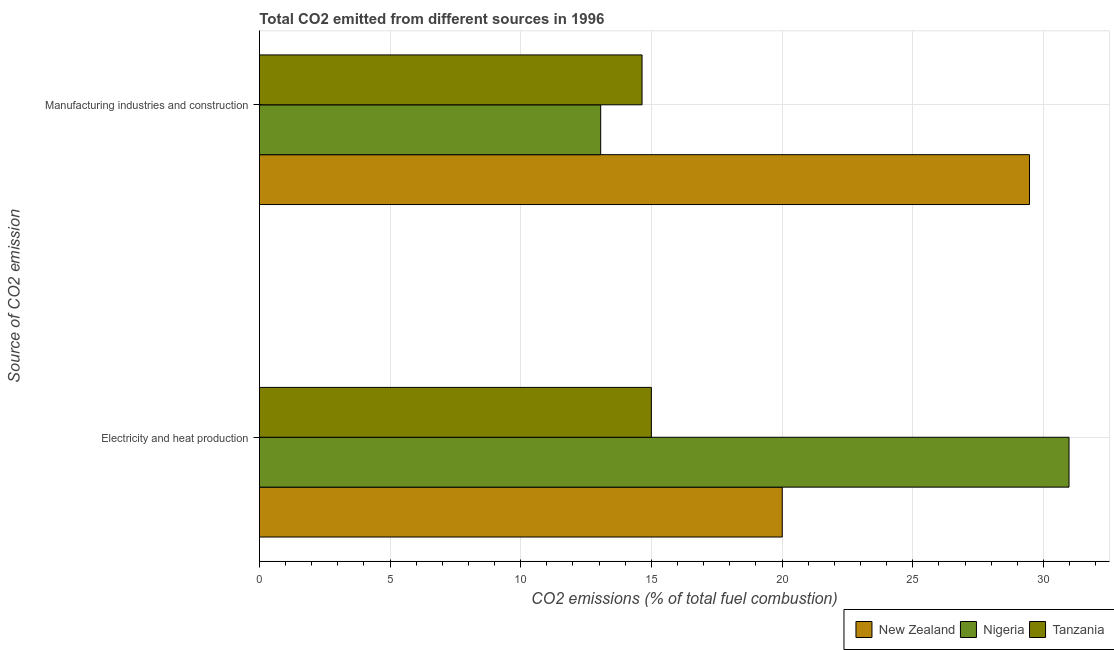Are the number of bars per tick equal to the number of legend labels?
Provide a short and direct response. Yes. How many bars are there on the 1st tick from the top?
Your answer should be compact. 3. What is the label of the 2nd group of bars from the top?
Provide a succinct answer. Electricity and heat production. What is the co2 emissions due to manufacturing industries in Tanzania?
Give a very brief answer. 14.64. Across all countries, what is the maximum co2 emissions due to manufacturing industries?
Provide a short and direct response. 29.47. Across all countries, what is the minimum co2 emissions due to manufacturing industries?
Provide a short and direct response. 13.06. In which country was the co2 emissions due to manufacturing industries maximum?
Ensure brevity in your answer.  New Zealand. In which country was the co2 emissions due to manufacturing industries minimum?
Offer a terse response. Nigeria. What is the total co2 emissions due to electricity and heat production in the graph?
Ensure brevity in your answer.  65.99. What is the difference between the co2 emissions due to electricity and heat production in New Zealand and that in Tanzania?
Your response must be concise. 5.01. What is the difference between the co2 emissions due to electricity and heat production in Nigeria and the co2 emissions due to manufacturing industries in Tanzania?
Your answer should be very brief. 16.34. What is the average co2 emissions due to electricity and heat production per country?
Your answer should be very brief. 22. What is the difference between the co2 emissions due to manufacturing industries and co2 emissions due to electricity and heat production in Nigeria?
Your answer should be compact. -17.92. In how many countries, is the co2 emissions due to electricity and heat production greater than 17 %?
Your answer should be very brief. 2. What is the ratio of the co2 emissions due to manufacturing industries in Tanzania to that in Nigeria?
Offer a terse response. 1.12. In how many countries, is the co2 emissions due to electricity and heat production greater than the average co2 emissions due to electricity and heat production taken over all countries?
Make the answer very short. 1. What does the 3rd bar from the top in Electricity and heat production represents?
Provide a succinct answer. New Zealand. What does the 1st bar from the bottom in Manufacturing industries and construction represents?
Provide a succinct answer. New Zealand. How many bars are there?
Make the answer very short. 6. Are all the bars in the graph horizontal?
Provide a succinct answer. Yes. Are the values on the major ticks of X-axis written in scientific E-notation?
Ensure brevity in your answer.  No. Does the graph contain grids?
Your answer should be compact. Yes. How many legend labels are there?
Offer a very short reply. 3. What is the title of the graph?
Your answer should be compact. Total CO2 emitted from different sources in 1996. What is the label or title of the X-axis?
Keep it short and to the point. CO2 emissions (% of total fuel combustion). What is the label or title of the Y-axis?
Keep it short and to the point. Source of CO2 emission. What is the CO2 emissions (% of total fuel combustion) in New Zealand in Electricity and heat production?
Your answer should be very brief. 20.01. What is the CO2 emissions (% of total fuel combustion) in Nigeria in Electricity and heat production?
Offer a very short reply. 30.98. What is the CO2 emissions (% of total fuel combustion) in New Zealand in Manufacturing industries and construction?
Provide a succinct answer. 29.47. What is the CO2 emissions (% of total fuel combustion) of Nigeria in Manufacturing industries and construction?
Provide a short and direct response. 13.06. What is the CO2 emissions (% of total fuel combustion) of Tanzania in Manufacturing industries and construction?
Provide a succinct answer. 14.64. Across all Source of CO2 emission, what is the maximum CO2 emissions (% of total fuel combustion) of New Zealand?
Give a very brief answer. 29.47. Across all Source of CO2 emission, what is the maximum CO2 emissions (% of total fuel combustion) in Nigeria?
Provide a succinct answer. 30.98. Across all Source of CO2 emission, what is the maximum CO2 emissions (% of total fuel combustion) of Tanzania?
Offer a very short reply. 15. Across all Source of CO2 emission, what is the minimum CO2 emissions (% of total fuel combustion) of New Zealand?
Your response must be concise. 20.01. Across all Source of CO2 emission, what is the minimum CO2 emissions (% of total fuel combustion) of Nigeria?
Make the answer very short. 13.06. Across all Source of CO2 emission, what is the minimum CO2 emissions (% of total fuel combustion) of Tanzania?
Offer a terse response. 14.64. What is the total CO2 emissions (% of total fuel combustion) in New Zealand in the graph?
Offer a terse response. 49.47. What is the total CO2 emissions (% of total fuel combustion) of Nigeria in the graph?
Ensure brevity in your answer.  44.04. What is the total CO2 emissions (% of total fuel combustion) of Tanzania in the graph?
Ensure brevity in your answer.  29.64. What is the difference between the CO2 emissions (% of total fuel combustion) of New Zealand in Electricity and heat production and that in Manufacturing industries and construction?
Your response must be concise. -9.46. What is the difference between the CO2 emissions (% of total fuel combustion) in Nigeria in Electricity and heat production and that in Manufacturing industries and construction?
Give a very brief answer. 17.92. What is the difference between the CO2 emissions (% of total fuel combustion) in Tanzania in Electricity and heat production and that in Manufacturing industries and construction?
Offer a very short reply. 0.36. What is the difference between the CO2 emissions (% of total fuel combustion) in New Zealand in Electricity and heat production and the CO2 emissions (% of total fuel combustion) in Nigeria in Manufacturing industries and construction?
Provide a short and direct response. 6.95. What is the difference between the CO2 emissions (% of total fuel combustion) of New Zealand in Electricity and heat production and the CO2 emissions (% of total fuel combustion) of Tanzania in Manufacturing industries and construction?
Make the answer very short. 5.36. What is the difference between the CO2 emissions (% of total fuel combustion) of Nigeria in Electricity and heat production and the CO2 emissions (% of total fuel combustion) of Tanzania in Manufacturing industries and construction?
Keep it short and to the point. 16.34. What is the average CO2 emissions (% of total fuel combustion) of New Zealand per Source of CO2 emission?
Provide a succinct answer. 24.74. What is the average CO2 emissions (% of total fuel combustion) of Nigeria per Source of CO2 emission?
Keep it short and to the point. 22.02. What is the average CO2 emissions (% of total fuel combustion) of Tanzania per Source of CO2 emission?
Your answer should be very brief. 14.82. What is the difference between the CO2 emissions (% of total fuel combustion) in New Zealand and CO2 emissions (% of total fuel combustion) in Nigeria in Electricity and heat production?
Your answer should be compact. -10.97. What is the difference between the CO2 emissions (% of total fuel combustion) in New Zealand and CO2 emissions (% of total fuel combustion) in Tanzania in Electricity and heat production?
Your response must be concise. 5.01. What is the difference between the CO2 emissions (% of total fuel combustion) in Nigeria and CO2 emissions (% of total fuel combustion) in Tanzania in Electricity and heat production?
Ensure brevity in your answer.  15.98. What is the difference between the CO2 emissions (% of total fuel combustion) in New Zealand and CO2 emissions (% of total fuel combustion) in Nigeria in Manufacturing industries and construction?
Make the answer very short. 16.41. What is the difference between the CO2 emissions (% of total fuel combustion) of New Zealand and CO2 emissions (% of total fuel combustion) of Tanzania in Manufacturing industries and construction?
Your answer should be very brief. 14.82. What is the difference between the CO2 emissions (% of total fuel combustion) of Nigeria and CO2 emissions (% of total fuel combustion) of Tanzania in Manufacturing industries and construction?
Your response must be concise. -1.58. What is the ratio of the CO2 emissions (% of total fuel combustion) in New Zealand in Electricity and heat production to that in Manufacturing industries and construction?
Keep it short and to the point. 0.68. What is the ratio of the CO2 emissions (% of total fuel combustion) of Nigeria in Electricity and heat production to that in Manufacturing industries and construction?
Your answer should be very brief. 2.37. What is the ratio of the CO2 emissions (% of total fuel combustion) in Tanzania in Electricity and heat production to that in Manufacturing industries and construction?
Keep it short and to the point. 1.02. What is the difference between the highest and the second highest CO2 emissions (% of total fuel combustion) of New Zealand?
Offer a very short reply. 9.46. What is the difference between the highest and the second highest CO2 emissions (% of total fuel combustion) of Nigeria?
Provide a short and direct response. 17.92. What is the difference between the highest and the second highest CO2 emissions (% of total fuel combustion) of Tanzania?
Make the answer very short. 0.36. What is the difference between the highest and the lowest CO2 emissions (% of total fuel combustion) of New Zealand?
Provide a short and direct response. 9.46. What is the difference between the highest and the lowest CO2 emissions (% of total fuel combustion) of Nigeria?
Make the answer very short. 17.92. What is the difference between the highest and the lowest CO2 emissions (% of total fuel combustion) of Tanzania?
Your response must be concise. 0.36. 